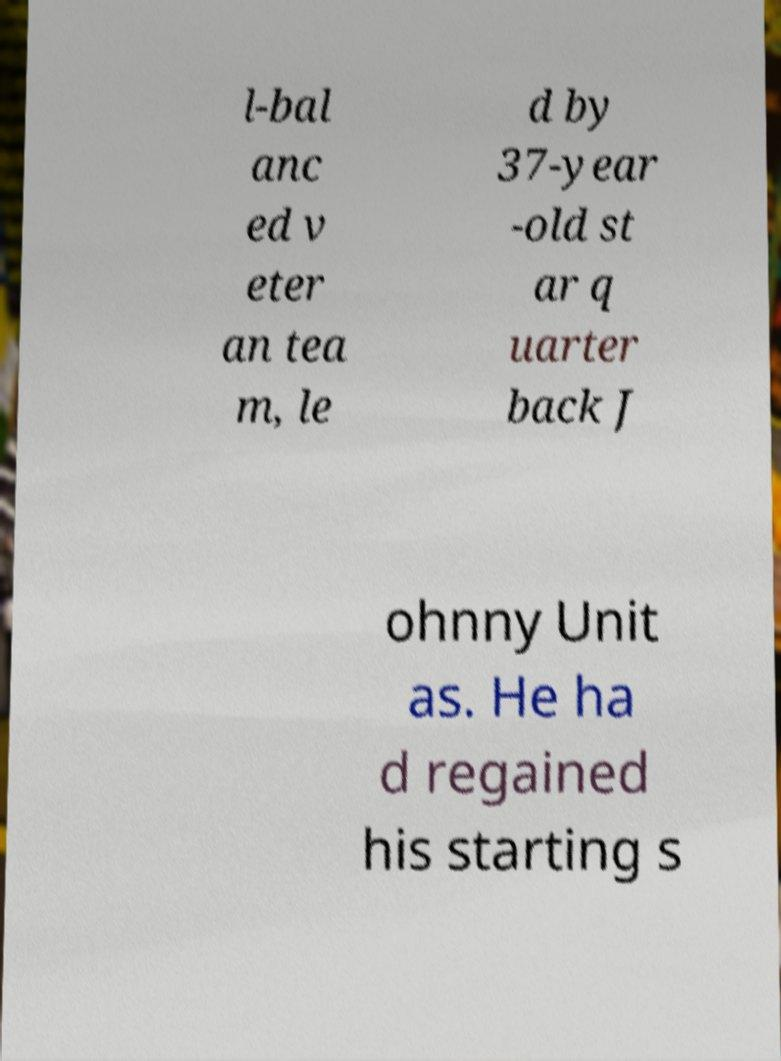Can you read and provide the text displayed in the image?This photo seems to have some interesting text. Can you extract and type it out for me? l-bal anc ed v eter an tea m, le d by 37-year -old st ar q uarter back J ohnny Unit as. He ha d regained his starting s 